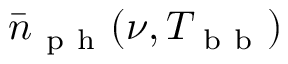Convert formula to latex. <formula><loc_0><loc_0><loc_500><loc_500>\bar { n } _ { p h } ( \nu , T _ { b b } )</formula> 